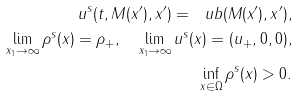Convert formula to latex. <formula><loc_0><loc_0><loc_500><loc_500>u ^ { s } ( t , M ( x ^ { \prime } ) , x ^ { \prime } ) = \ u b ( M ( x ^ { \prime } ) , x ^ { \prime } ) , \\ \lim _ { x _ { 1 } \to \infty } \rho ^ { s } ( x ) = \rho _ { + } , \quad \lim _ { x _ { 1 } \to \infty } u ^ { s } ( x ) = ( u _ { + } , 0 , 0 ) , \\ \inf _ { x \in \Omega } \rho ^ { s } ( x ) > 0 .</formula> 